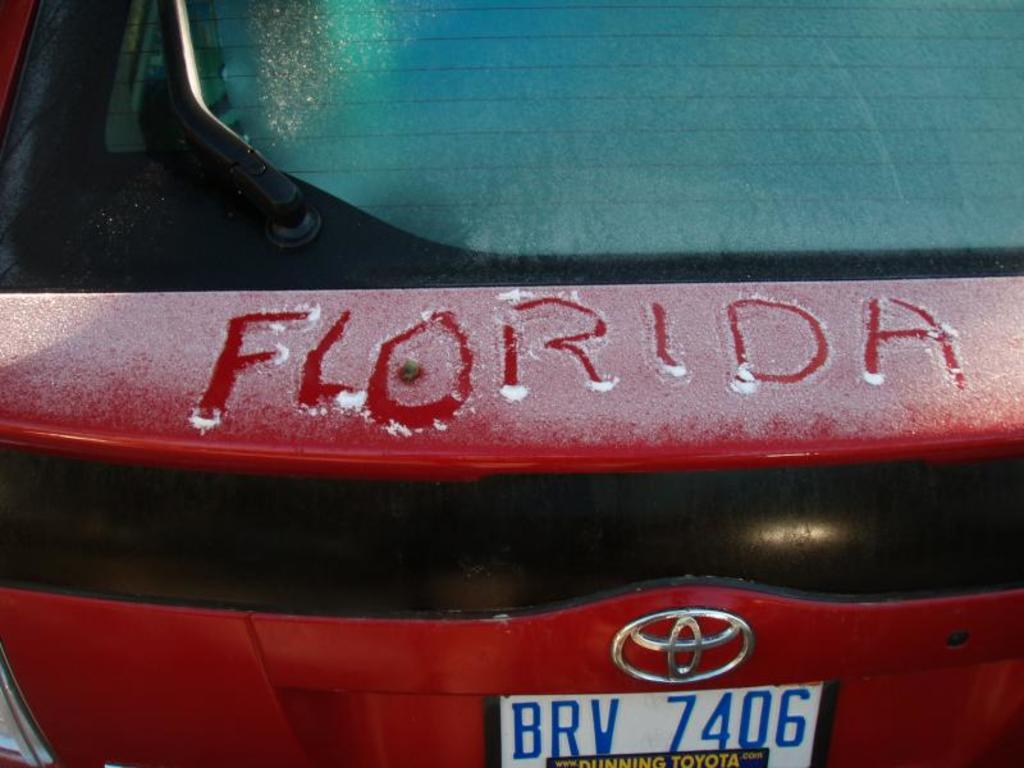<image>
Give a short and clear explanation of the subsequent image. A red sedans back side with the word florida written on the snow. 